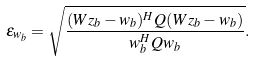<formula> <loc_0><loc_0><loc_500><loc_500>\epsilon _ { w _ { b } } = \sqrt { \frac { ( W z _ { b } - w _ { b } ) ^ { H } Q ( W z _ { b } - w _ { b } ) } { w _ { b } ^ { H } Q { w _ { b } } } } .</formula> 